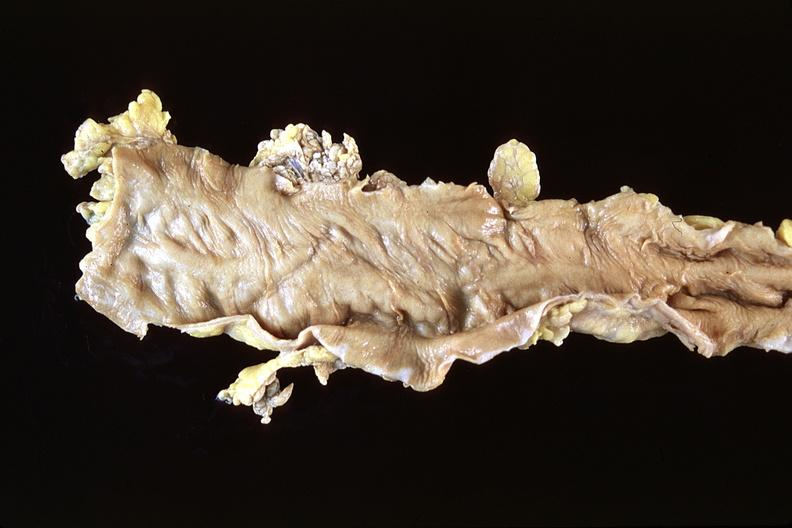s gastrointestinal present?
Answer the question using a single word or phrase. Yes 